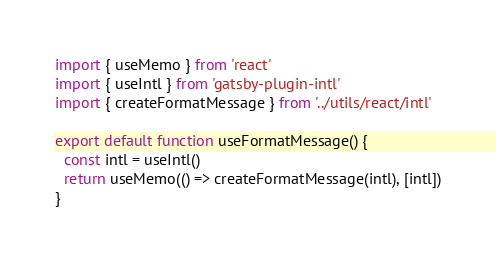Convert code to text. <code><loc_0><loc_0><loc_500><loc_500><_TypeScript_>import { useMemo } from 'react'
import { useIntl } from 'gatsby-plugin-intl'
import { createFormatMessage } from '../utils/react/intl'

export default function useFormatMessage() {
  const intl = useIntl()
  return useMemo(() => createFormatMessage(intl), [intl])
}
</code> 